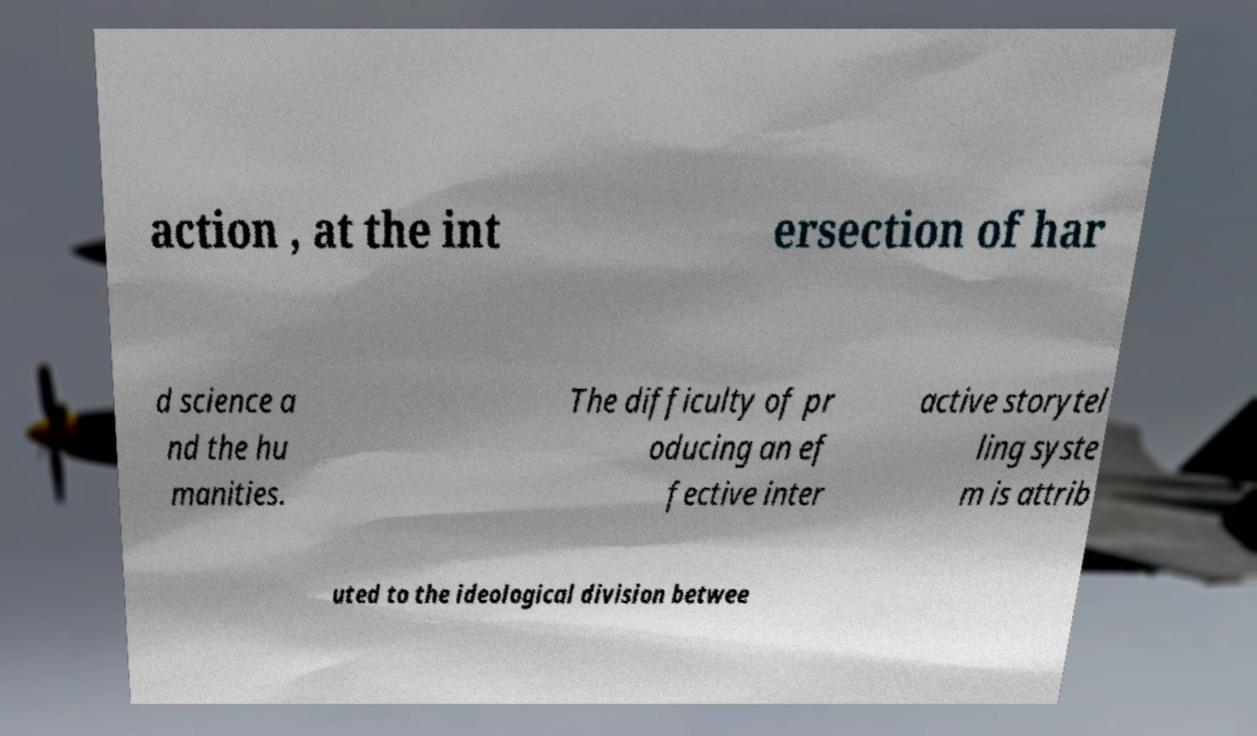There's text embedded in this image that I need extracted. Can you transcribe it verbatim? action , at the int ersection of har d science a nd the hu manities. The difficulty of pr oducing an ef fective inter active storytel ling syste m is attrib uted to the ideological division betwee 